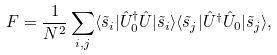<formula> <loc_0><loc_0><loc_500><loc_500>F = \frac { 1 } { N ^ { 2 } } \sum _ { i , j } \langle \tilde { s } _ { i } | \hat { U } _ { 0 } ^ { \dagger } \hat { U } | \tilde { s } _ { i } \rangle \langle \tilde { s } _ { j } | \hat { U } ^ { \dagger } \hat { U } _ { 0 } | \tilde { s } _ { j } \rangle ,</formula> 